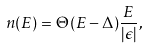Convert formula to latex. <formula><loc_0><loc_0><loc_500><loc_500>n ( E ) = \Theta ( E - \Delta ) \frac { E } { | \epsilon | } ,</formula> 